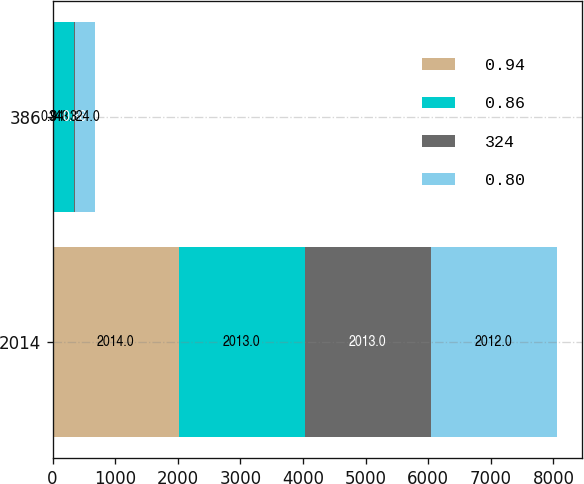Convert chart. <chart><loc_0><loc_0><loc_500><loc_500><stacked_bar_chart><ecel><fcel>2014<fcel>386<nl><fcel>0.94<fcel>2014<fcel>0.94<nl><fcel>0.86<fcel>2013<fcel>348<nl><fcel>324<fcel>2013<fcel>0.86<nl><fcel>0.8<fcel>2012<fcel>324<nl></chart> 